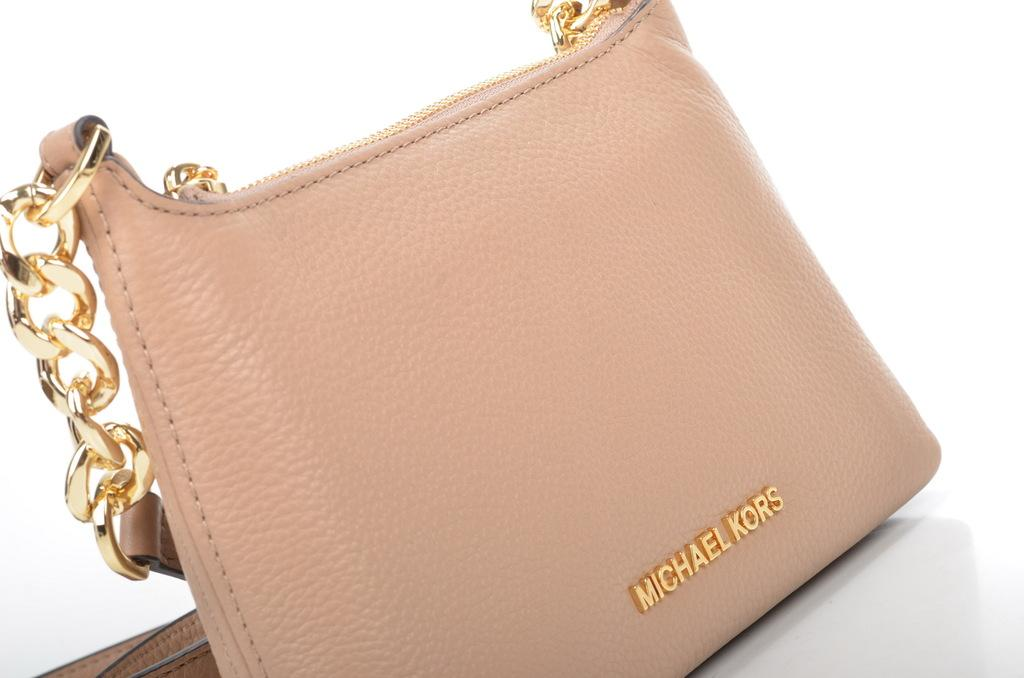What object can be seen in the image? There is a handbag in the image. What is the color of the handbag? The handbag is cream in color. How many eyes does the tramp have in the image? There is no tramp present in the image, so it is not possible to determine the number of eyes. 